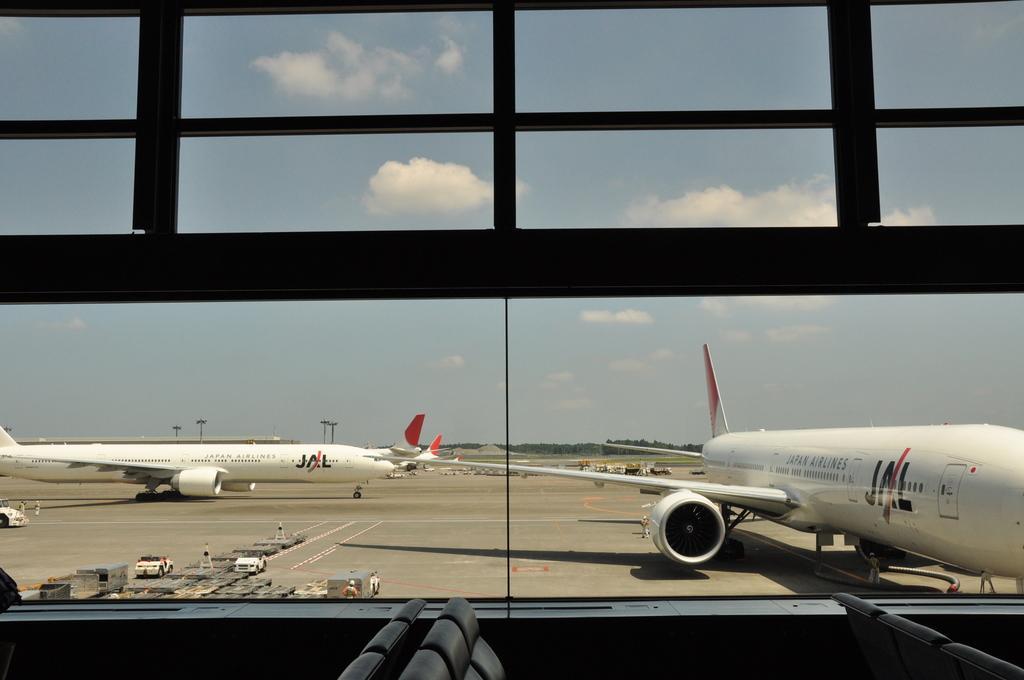Please provide a concise description of this image. In this image I can see some plane on the ground, and there is some vehicle at the bottom left hand corner. And the background is the sky. 